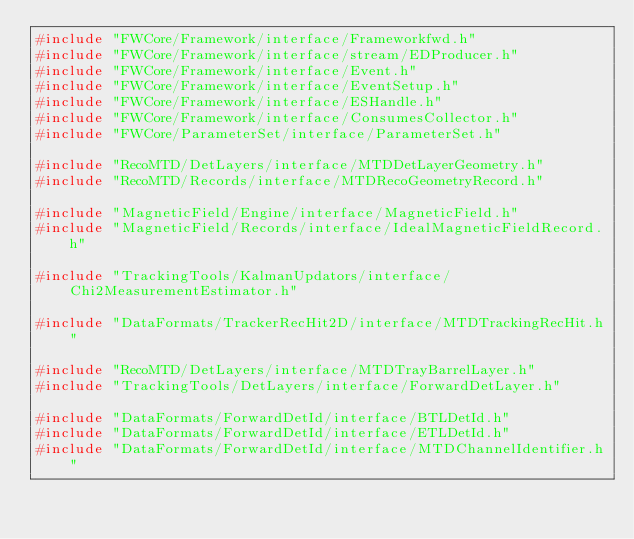<code> <loc_0><loc_0><loc_500><loc_500><_C++_>#include "FWCore/Framework/interface/Frameworkfwd.h"
#include "FWCore/Framework/interface/stream/EDProducer.h"
#include "FWCore/Framework/interface/Event.h"
#include "FWCore/Framework/interface/EventSetup.h"
#include "FWCore/Framework/interface/ESHandle.h"
#include "FWCore/Framework/interface/ConsumesCollector.h"
#include "FWCore/ParameterSet/interface/ParameterSet.h"

#include "RecoMTD/DetLayers/interface/MTDDetLayerGeometry.h"
#include "RecoMTD/Records/interface/MTDRecoGeometryRecord.h"

#include "MagneticField/Engine/interface/MagneticField.h"
#include "MagneticField/Records/interface/IdealMagneticFieldRecord.h"

#include "TrackingTools/KalmanUpdators/interface/Chi2MeasurementEstimator.h"

#include "DataFormats/TrackerRecHit2D/interface/MTDTrackingRecHit.h"

#include "RecoMTD/DetLayers/interface/MTDTrayBarrelLayer.h"
#include "TrackingTools/DetLayers/interface/ForwardDetLayer.h"

#include "DataFormats/ForwardDetId/interface/BTLDetId.h"
#include "DataFormats/ForwardDetId/interface/ETLDetId.h"
#include "DataFormats/ForwardDetId/interface/MTDChannelIdentifier.h"</code> 